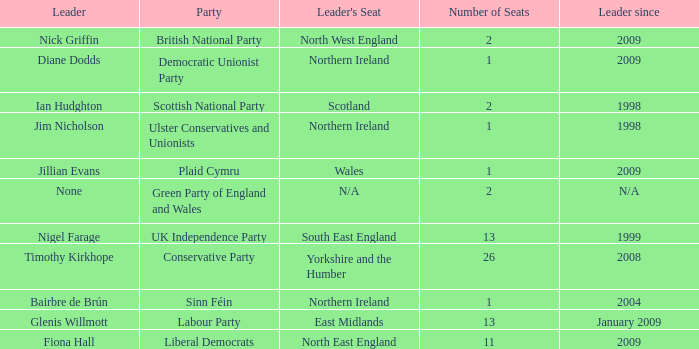Which party does Timothy Kirkhope lead? Conservative Party. 